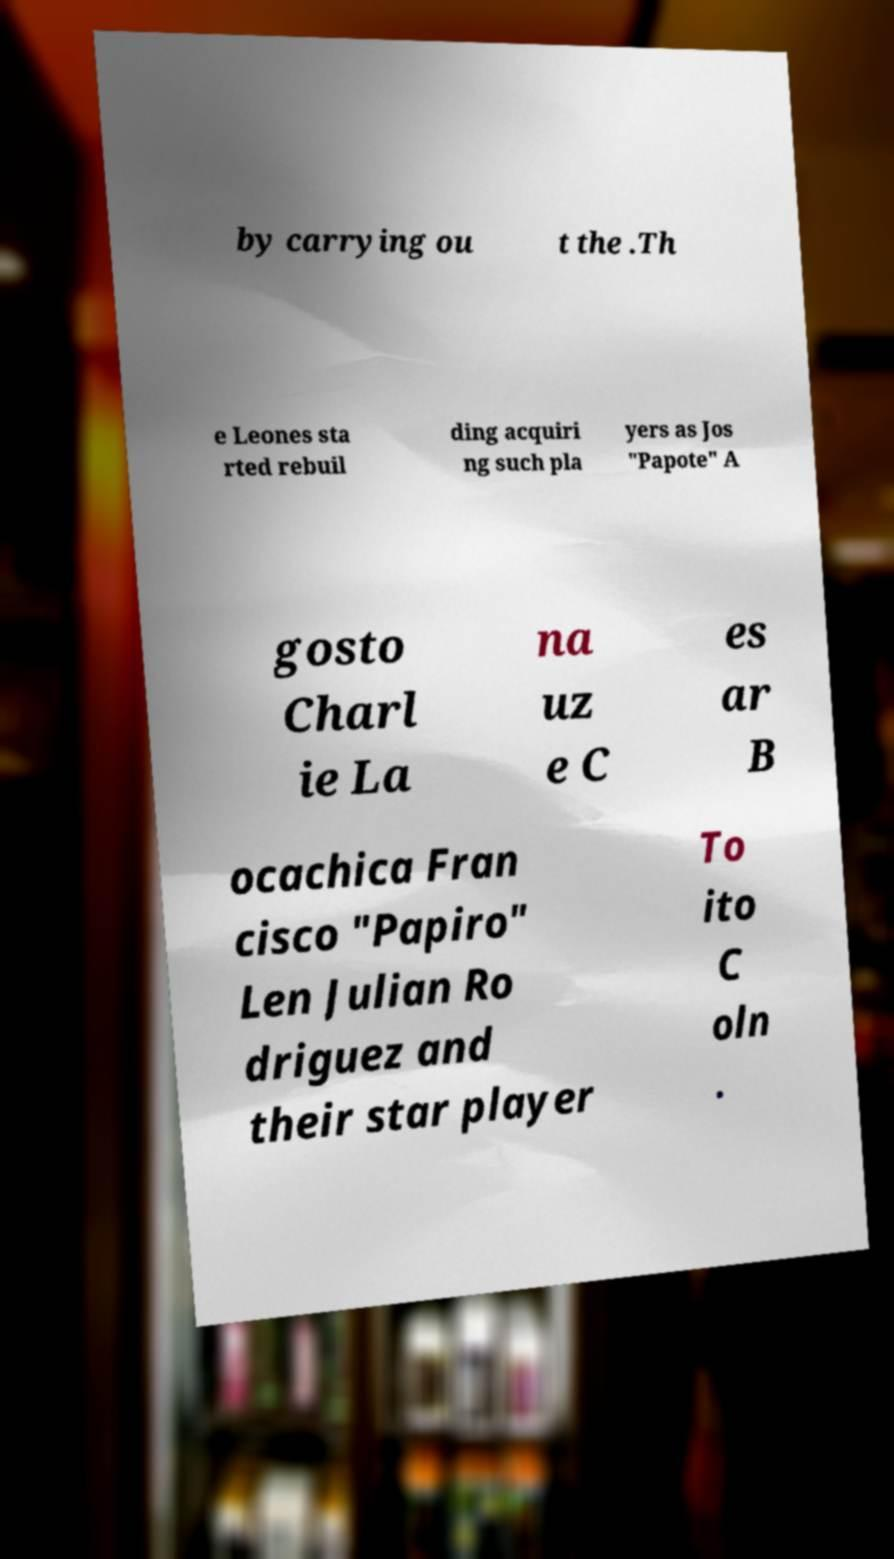Please read and relay the text visible in this image. What does it say? by carrying ou t the .Th e Leones sta rted rebuil ding acquiri ng such pla yers as Jos "Papote" A gosto Charl ie La na uz e C es ar B ocachica Fran cisco "Papiro" Len Julian Ro driguez and their star player To ito C oln . 